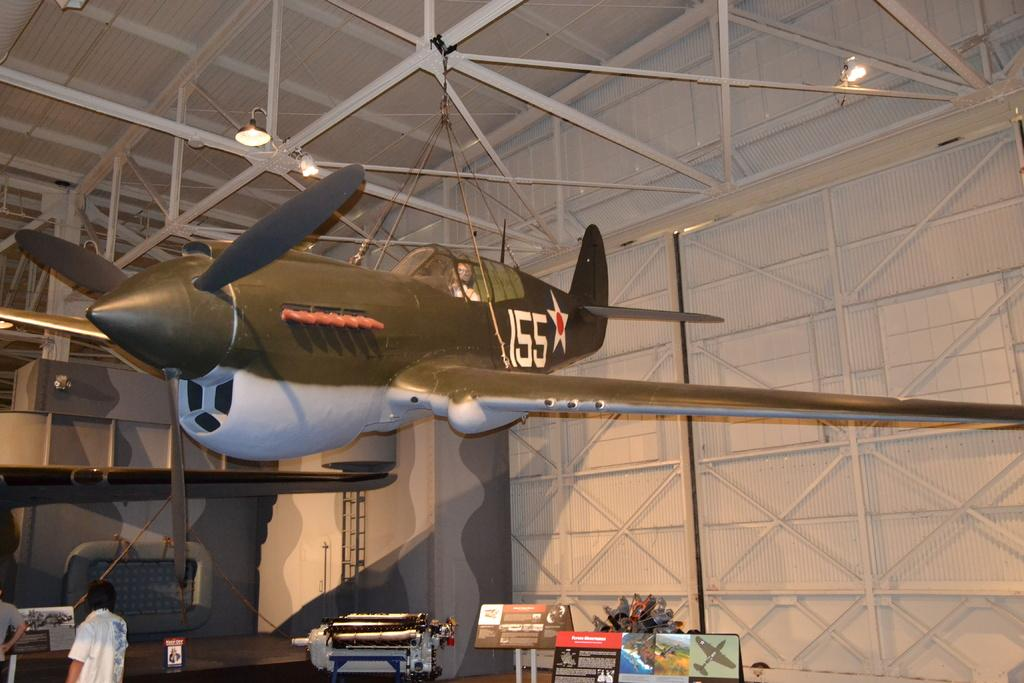<image>
Share a concise interpretation of the image provided. A plane is in a building with the number 155 on the tail. 